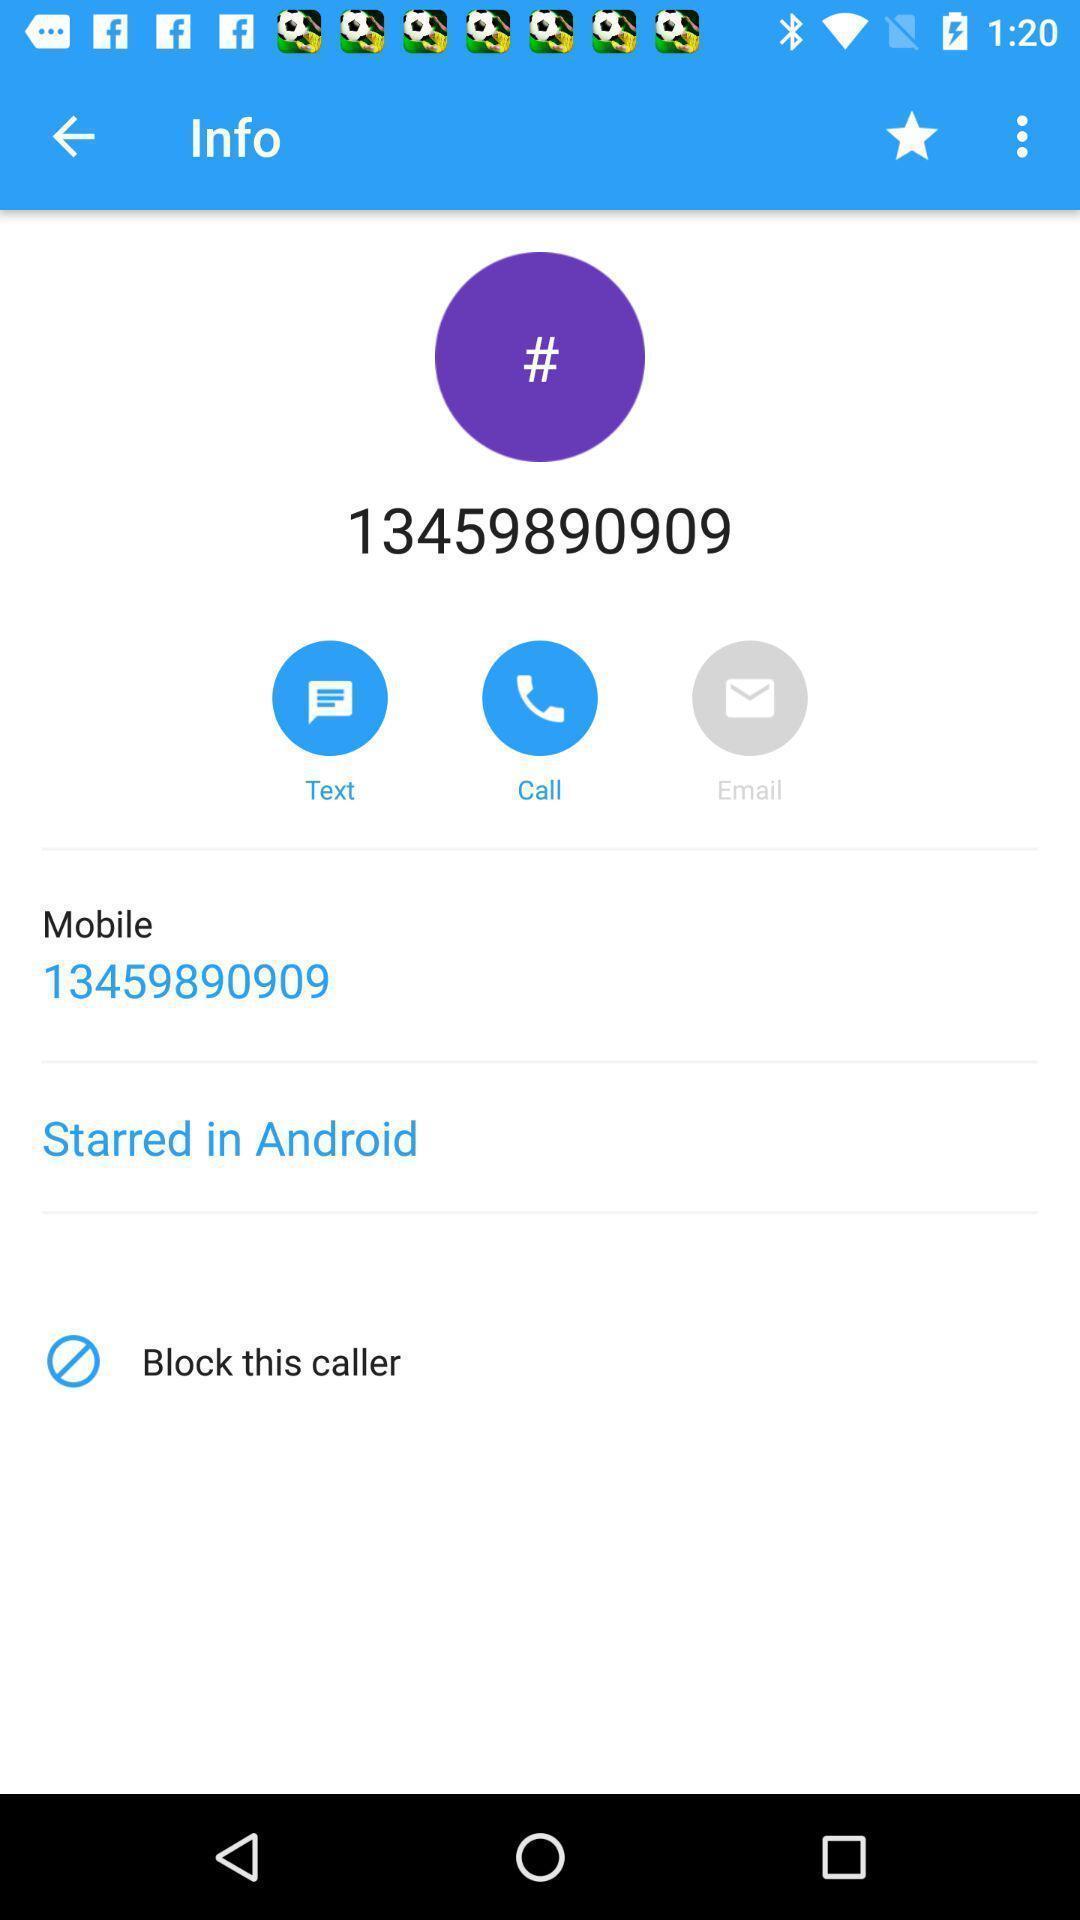Describe the key features of this screenshot. Screen display about information page in caller id app. 